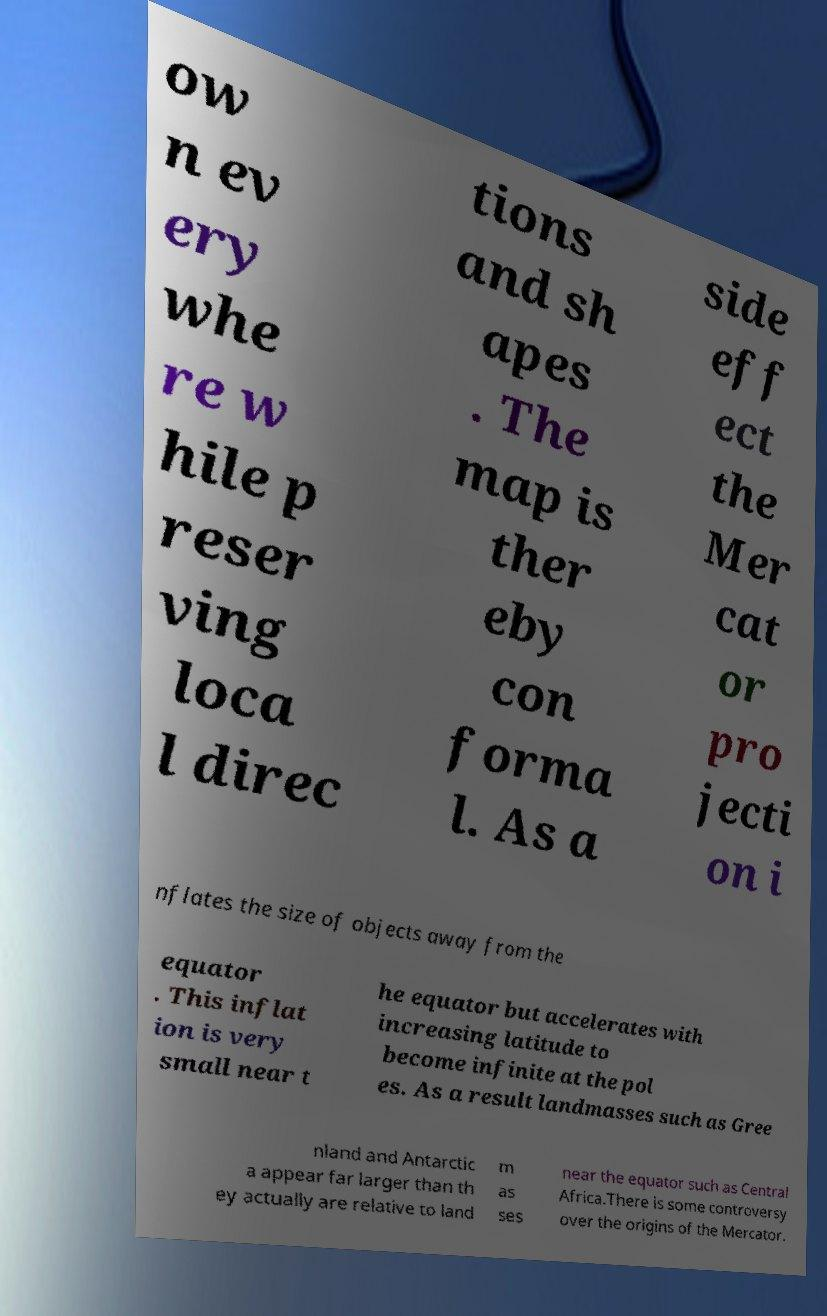Please identify and transcribe the text found in this image. ow n ev ery whe re w hile p reser ving loca l direc tions and sh apes . The map is ther eby con forma l. As a side eff ect the Mer cat or pro jecti on i nflates the size of objects away from the equator . This inflat ion is very small near t he equator but accelerates with increasing latitude to become infinite at the pol es. As a result landmasses such as Gree nland and Antarctic a appear far larger than th ey actually are relative to land m as ses near the equator such as Central Africa.There is some controversy over the origins of the Mercator. 